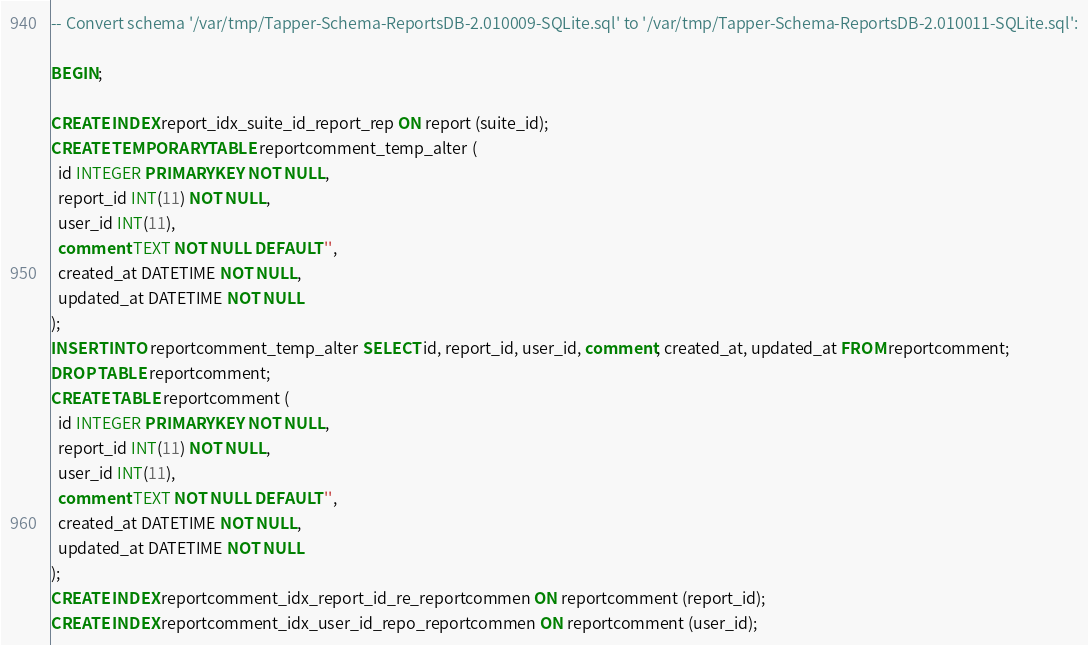<code> <loc_0><loc_0><loc_500><loc_500><_SQL_>-- Convert schema '/var/tmp/Tapper-Schema-ReportsDB-2.010009-SQLite.sql' to '/var/tmp/Tapper-Schema-ReportsDB-2.010011-SQLite.sql':

BEGIN;

CREATE INDEX report_idx_suite_id_report_rep ON report (suite_id);
CREATE TEMPORARY TABLE reportcomment_temp_alter (
  id INTEGER PRIMARY KEY NOT NULL,
  report_id INT(11) NOT NULL,
  user_id INT(11),
  comment TEXT NOT NULL DEFAULT '',
  created_at DATETIME NOT NULL,
  updated_at DATETIME NOT NULL
);
INSERT INTO reportcomment_temp_alter SELECT id, report_id, user_id, comment, created_at, updated_at FROM reportcomment;
DROP TABLE reportcomment;
CREATE TABLE reportcomment (
  id INTEGER PRIMARY KEY NOT NULL,
  report_id INT(11) NOT NULL,
  user_id INT(11),
  comment TEXT NOT NULL DEFAULT '',
  created_at DATETIME NOT NULL,
  updated_at DATETIME NOT NULL
);
CREATE INDEX reportcomment_idx_report_id_re_reportcommen ON reportcomment (report_id);
CREATE INDEX reportcomment_idx_user_id_repo_reportcommen ON reportcomment (user_id);</code> 